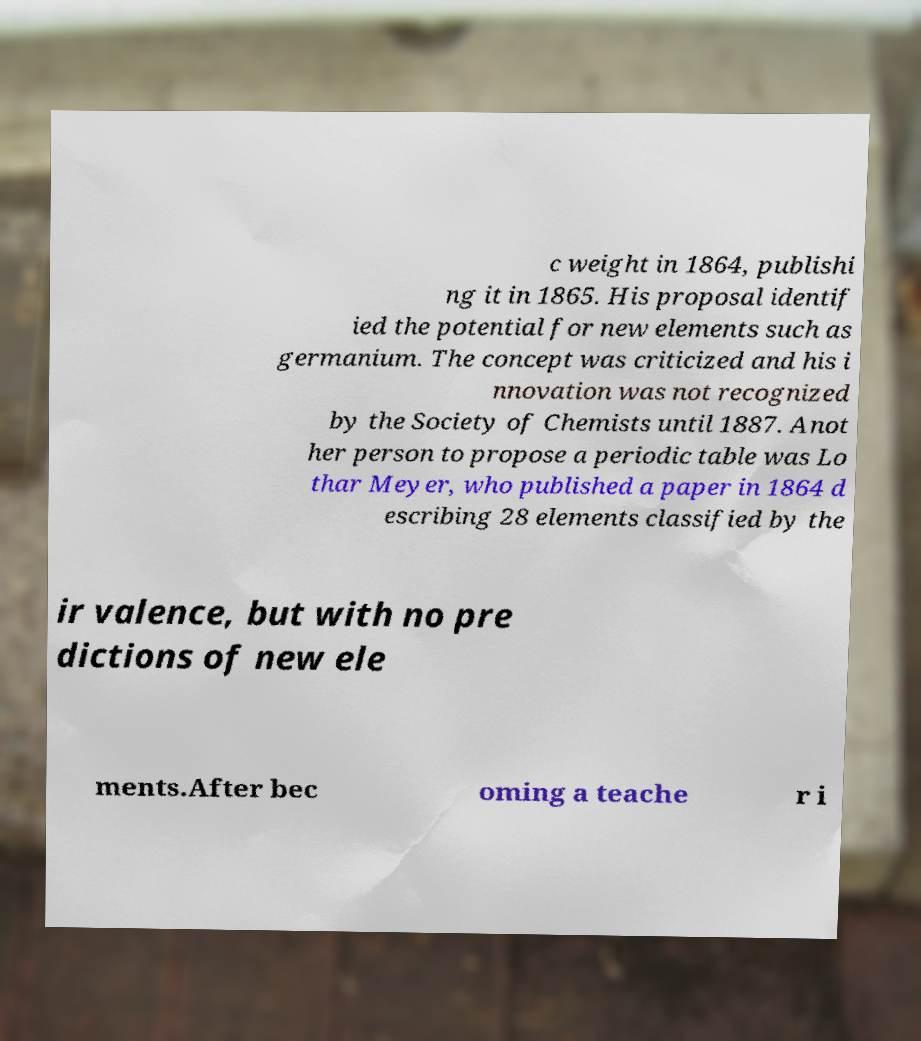Can you accurately transcribe the text from the provided image for me? c weight in 1864, publishi ng it in 1865. His proposal identif ied the potential for new elements such as germanium. The concept was criticized and his i nnovation was not recognized by the Society of Chemists until 1887. Anot her person to propose a periodic table was Lo thar Meyer, who published a paper in 1864 d escribing 28 elements classified by the ir valence, but with no pre dictions of new ele ments.After bec oming a teache r i 